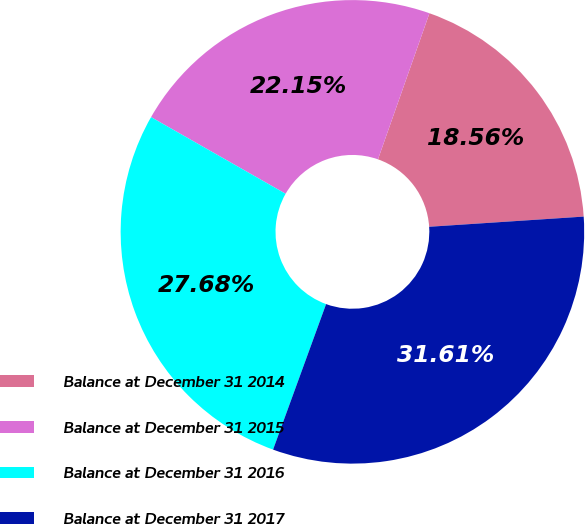Convert chart. <chart><loc_0><loc_0><loc_500><loc_500><pie_chart><fcel>Balance at December 31 2014<fcel>Balance at December 31 2015<fcel>Balance at December 31 2016<fcel>Balance at December 31 2017<nl><fcel>18.56%<fcel>22.15%<fcel>27.68%<fcel>31.61%<nl></chart> 